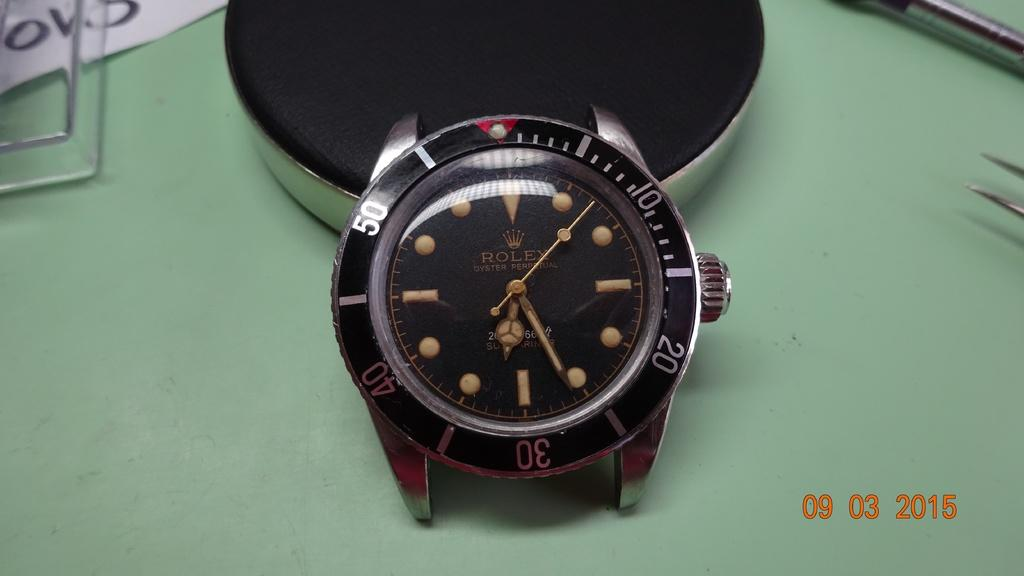<image>
Describe the image concisely. A luxury watch from the brand Rolex is on a green table. 